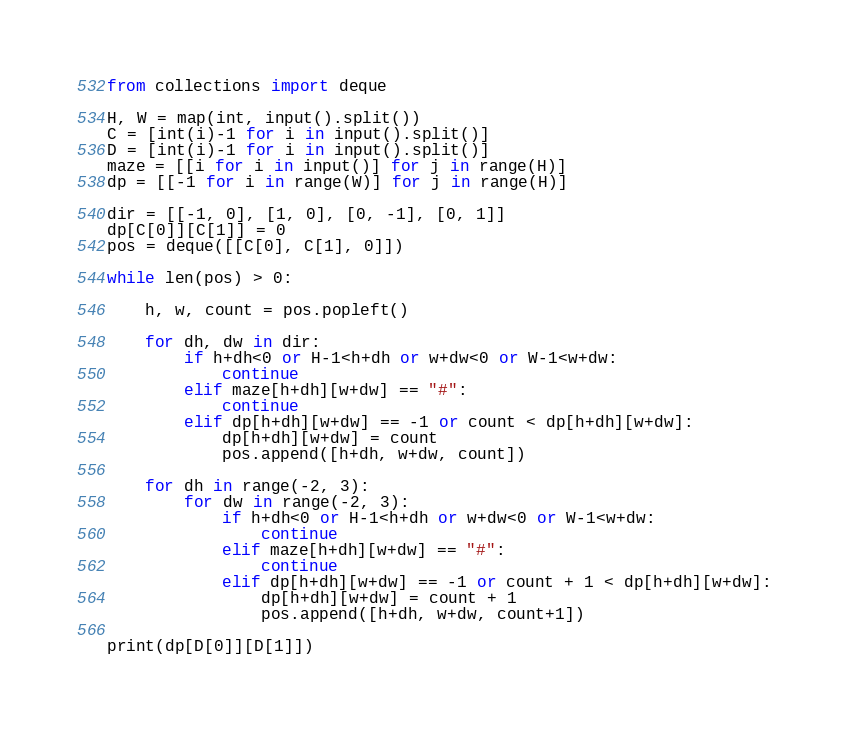Convert code to text. <code><loc_0><loc_0><loc_500><loc_500><_Python_>from collections import deque

H, W = map(int, input().split())
C = [int(i)-1 for i in input().split()]
D = [int(i)-1 for i in input().split()]
maze = [[i for i in input()] for j in range(H)]
dp = [[-1 for i in range(W)] for j in range(H)]

dir = [[-1, 0], [1, 0], [0, -1], [0, 1]]
dp[C[0]][C[1]] = 0
pos = deque([[C[0], C[1], 0]])

while len(pos) > 0:

    h, w, count = pos.popleft()

    for dh, dw in dir:
        if h+dh<0 or H-1<h+dh or w+dw<0 or W-1<w+dw:
            continue
        elif maze[h+dh][w+dw] == "#":
            continue
        elif dp[h+dh][w+dw] == -1 or count < dp[h+dh][w+dw]:
            dp[h+dh][w+dw] = count
            pos.append([h+dh, w+dw, count])

    for dh in range(-2, 3):
        for dw in range(-2, 3):
            if h+dh<0 or H-1<h+dh or w+dw<0 or W-1<w+dw:
                continue
            elif maze[h+dh][w+dw] == "#":
                continue
            elif dp[h+dh][w+dw] == -1 or count + 1 < dp[h+dh][w+dw]:
                dp[h+dh][w+dw] = count + 1
                pos.append([h+dh, w+dw, count+1])

print(dp[D[0]][D[1]])</code> 